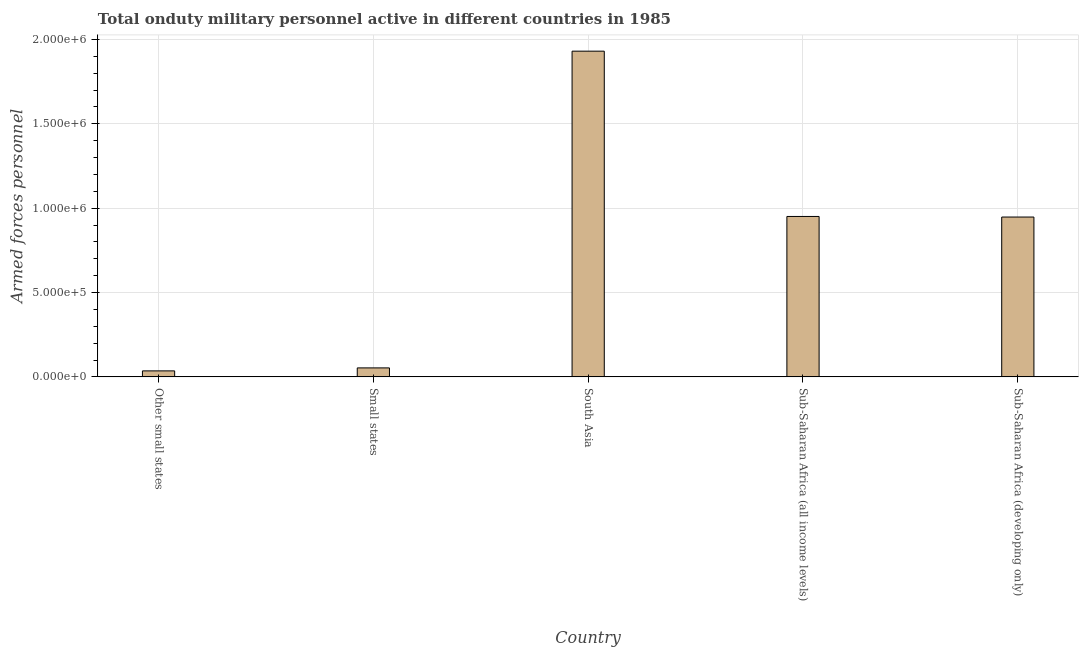Does the graph contain grids?
Offer a terse response. Yes. What is the title of the graph?
Make the answer very short. Total onduty military personnel active in different countries in 1985. What is the label or title of the Y-axis?
Make the answer very short. Armed forces personnel. What is the number of armed forces personnel in Sub-Saharan Africa (all income levels)?
Make the answer very short. 9.51e+05. Across all countries, what is the maximum number of armed forces personnel?
Make the answer very short. 1.93e+06. Across all countries, what is the minimum number of armed forces personnel?
Ensure brevity in your answer.  3.55e+04. In which country was the number of armed forces personnel maximum?
Ensure brevity in your answer.  South Asia. In which country was the number of armed forces personnel minimum?
Keep it short and to the point. Other small states. What is the sum of the number of armed forces personnel?
Make the answer very short. 3.92e+06. What is the difference between the number of armed forces personnel in Other small states and Sub-Saharan Africa (developing only)?
Make the answer very short. -9.12e+05. What is the average number of armed forces personnel per country?
Ensure brevity in your answer.  7.84e+05. What is the median number of armed forces personnel?
Offer a very short reply. 9.47e+05. In how many countries, is the number of armed forces personnel greater than 700000 ?
Your response must be concise. 3. What is the ratio of the number of armed forces personnel in South Asia to that in Sub-Saharan Africa (developing only)?
Offer a terse response. 2.04. Is the number of armed forces personnel in South Asia less than that in Sub-Saharan Africa (all income levels)?
Ensure brevity in your answer.  No. Is the difference between the number of armed forces personnel in Other small states and Sub-Saharan Africa (all income levels) greater than the difference between any two countries?
Offer a very short reply. No. What is the difference between the highest and the second highest number of armed forces personnel?
Offer a terse response. 9.80e+05. Is the sum of the number of armed forces personnel in Small states and Sub-Saharan Africa (all income levels) greater than the maximum number of armed forces personnel across all countries?
Make the answer very short. No. What is the difference between the highest and the lowest number of armed forces personnel?
Ensure brevity in your answer.  1.90e+06. Are the values on the major ticks of Y-axis written in scientific E-notation?
Provide a succinct answer. Yes. What is the Armed forces personnel of Other small states?
Your response must be concise. 3.55e+04. What is the Armed forces personnel of Small states?
Provide a succinct answer. 5.32e+04. What is the Armed forces personnel in South Asia?
Provide a succinct answer. 1.93e+06. What is the Armed forces personnel of Sub-Saharan Africa (all income levels)?
Provide a succinct answer. 9.51e+05. What is the Armed forces personnel in Sub-Saharan Africa (developing only)?
Keep it short and to the point. 9.47e+05. What is the difference between the Armed forces personnel in Other small states and Small states?
Make the answer very short. -1.77e+04. What is the difference between the Armed forces personnel in Other small states and South Asia?
Your answer should be very brief. -1.90e+06. What is the difference between the Armed forces personnel in Other small states and Sub-Saharan Africa (all income levels)?
Make the answer very short. -9.15e+05. What is the difference between the Armed forces personnel in Other small states and Sub-Saharan Africa (developing only)?
Offer a terse response. -9.12e+05. What is the difference between the Armed forces personnel in Small states and South Asia?
Your answer should be compact. -1.88e+06. What is the difference between the Armed forces personnel in Small states and Sub-Saharan Africa (all income levels)?
Make the answer very short. -8.98e+05. What is the difference between the Armed forces personnel in Small states and Sub-Saharan Africa (developing only)?
Make the answer very short. -8.94e+05. What is the difference between the Armed forces personnel in South Asia and Sub-Saharan Africa (all income levels)?
Give a very brief answer. 9.80e+05. What is the difference between the Armed forces personnel in South Asia and Sub-Saharan Africa (developing only)?
Your response must be concise. 9.83e+05. What is the difference between the Armed forces personnel in Sub-Saharan Africa (all income levels) and Sub-Saharan Africa (developing only)?
Make the answer very short. 3400. What is the ratio of the Armed forces personnel in Other small states to that in Small states?
Offer a very short reply. 0.67. What is the ratio of the Armed forces personnel in Other small states to that in South Asia?
Make the answer very short. 0.02. What is the ratio of the Armed forces personnel in Other small states to that in Sub-Saharan Africa (all income levels)?
Give a very brief answer. 0.04. What is the ratio of the Armed forces personnel in Other small states to that in Sub-Saharan Africa (developing only)?
Keep it short and to the point. 0.04. What is the ratio of the Armed forces personnel in Small states to that in South Asia?
Ensure brevity in your answer.  0.03. What is the ratio of the Armed forces personnel in Small states to that in Sub-Saharan Africa (all income levels)?
Offer a very short reply. 0.06. What is the ratio of the Armed forces personnel in Small states to that in Sub-Saharan Africa (developing only)?
Offer a very short reply. 0.06. What is the ratio of the Armed forces personnel in South Asia to that in Sub-Saharan Africa (all income levels)?
Your response must be concise. 2.03. What is the ratio of the Armed forces personnel in South Asia to that in Sub-Saharan Africa (developing only)?
Give a very brief answer. 2.04. What is the ratio of the Armed forces personnel in Sub-Saharan Africa (all income levels) to that in Sub-Saharan Africa (developing only)?
Ensure brevity in your answer.  1. 